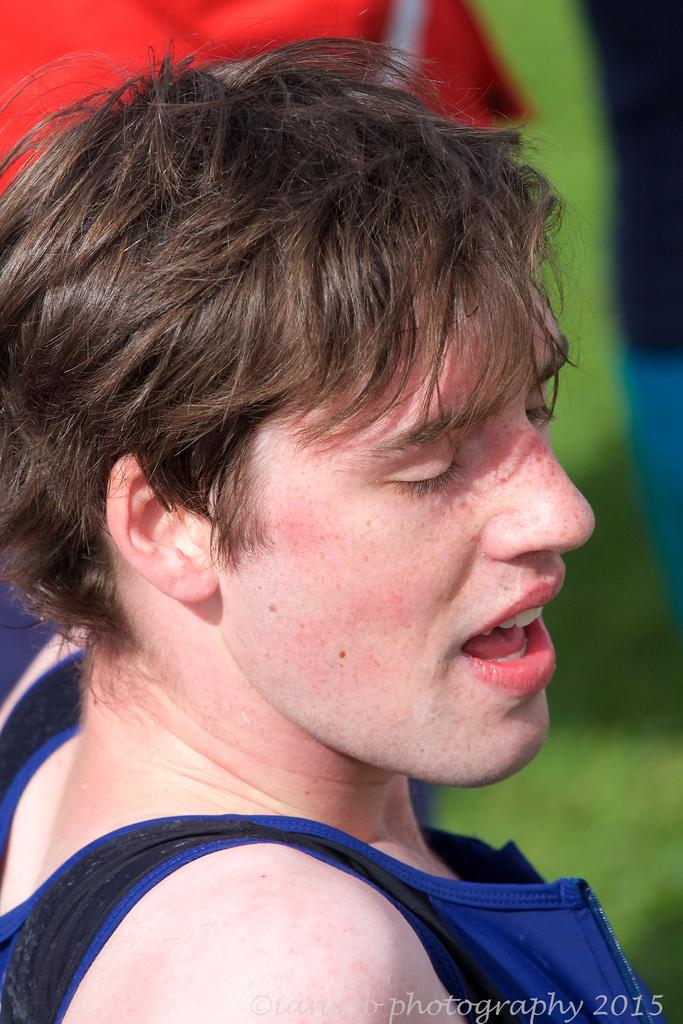What is the main subject of the image? There is a person in the image. Can you describe the background of the image? The background of the image is blurred. Is there any additional information or markings on the image? Yes, there is a watermark at the bottom of the image. What type of pain is the person experiencing in the image? There is no indication of pain or any emotional state in the image; it only shows a person with a blurred background and a watermark. 